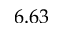Convert formula to latex. <formula><loc_0><loc_0><loc_500><loc_500>6 . 6 3</formula> 